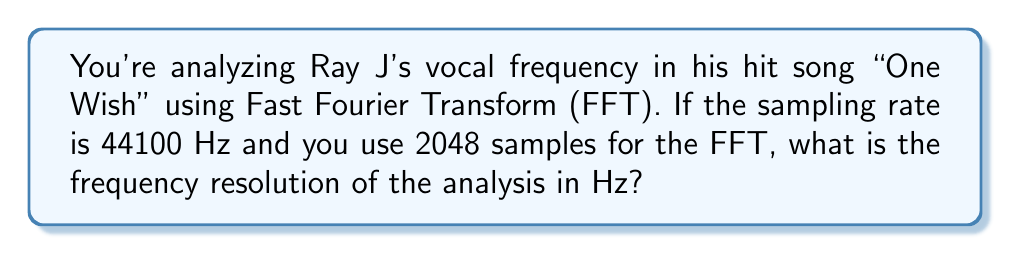What is the answer to this math problem? To solve this problem, we need to understand the relationship between the sampling rate, number of samples, and frequency resolution in FFT analysis. Here's the step-by-step explanation:

1. The frequency resolution in FFT is given by the formula:

   $$\Delta f = \frac{f_s}{N}$$

   Where:
   $\Delta f$ is the frequency resolution
   $f_s$ is the sampling rate
   $N$ is the number of samples used in the FFT

2. We're given:
   $f_s = 44100$ Hz
   $N = 2048$ samples

3. Substituting these values into the formula:

   $$\Delta f = \frac{44100}{2048}$$

4. Perform the division:

   $$\Delta f = 21.533203125$$ Hz

5. Round to a reasonable number of decimal places for audio analysis:

   $$\Delta f \approx 21.53$$ Hz

This means that in the FFT analysis of Ray J's vocals, we can distinguish between frequencies that are about 21.53 Hz apart.
Answer: 21.53 Hz 